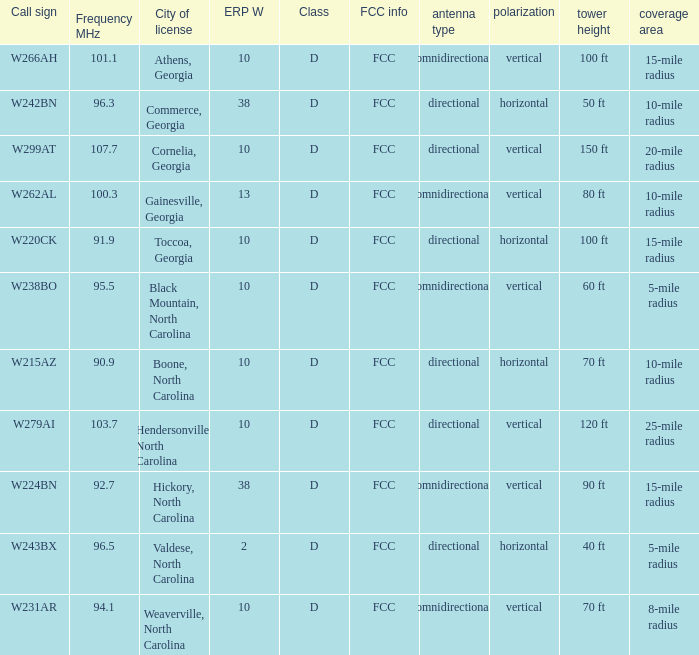Would you be able to parse every entry in this table? {'header': ['Call sign', 'Frequency MHz', 'City of license', 'ERP W', 'Class', 'FCC info', 'antenna type', 'polarization', 'tower height', 'coverage area'], 'rows': [['W266AH', '101.1', 'Athens, Georgia', '10', 'D', 'FCC', 'omnidirectional', 'vertical', '100 ft', '15-mile radius'], ['W242BN', '96.3', 'Commerce, Georgia', '38', 'D', 'FCC', 'directional', 'horizontal', '50 ft', '10-mile radius'], ['W299AT', '107.7', 'Cornelia, Georgia', '10', 'D', 'FCC', 'directional', 'vertical', '150 ft', '20-mile radius'], ['W262AL', '100.3', 'Gainesville, Georgia', '13', 'D', 'FCC', 'omnidirectional', 'vertical', '80 ft', '10-mile radius'], ['W220CK', '91.9', 'Toccoa, Georgia', '10', 'D', 'FCC', 'directional', 'horizontal', '100 ft', '15-mile radius'], ['W238BO', '95.5', 'Black Mountain, North Carolina', '10', 'D', 'FCC', 'omnidirectional', 'vertical', '60 ft', '5-mile radius'], ['W215AZ', '90.9', 'Boone, North Carolina', '10', 'D', 'FCC', 'directional', 'horizontal', '70 ft', '10-mile radius'], ['W279AI', '103.7', 'Hendersonville, North Carolina', '10', 'D', 'FCC', 'directional', 'vertical', '120 ft', '25-mile radius'], ['W224BN', '92.7', 'Hickory, North Carolina', '38', 'D', 'FCC', 'omnidirectional', 'vertical', '90 ft', '15-mile radius'], ['W243BX', '96.5', 'Valdese, North Carolina', '2', 'D', 'FCC', 'directional', 'horizontal', '40 ft', '5-mile radius'], ['W231AR', '94.1', 'Weaverville, North Carolina', '10', 'D', 'FCC', 'omnidirectional', 'vertical', '70 ft', '8-mile radius']]} What class is the city of black mountain, north carolina? D. 